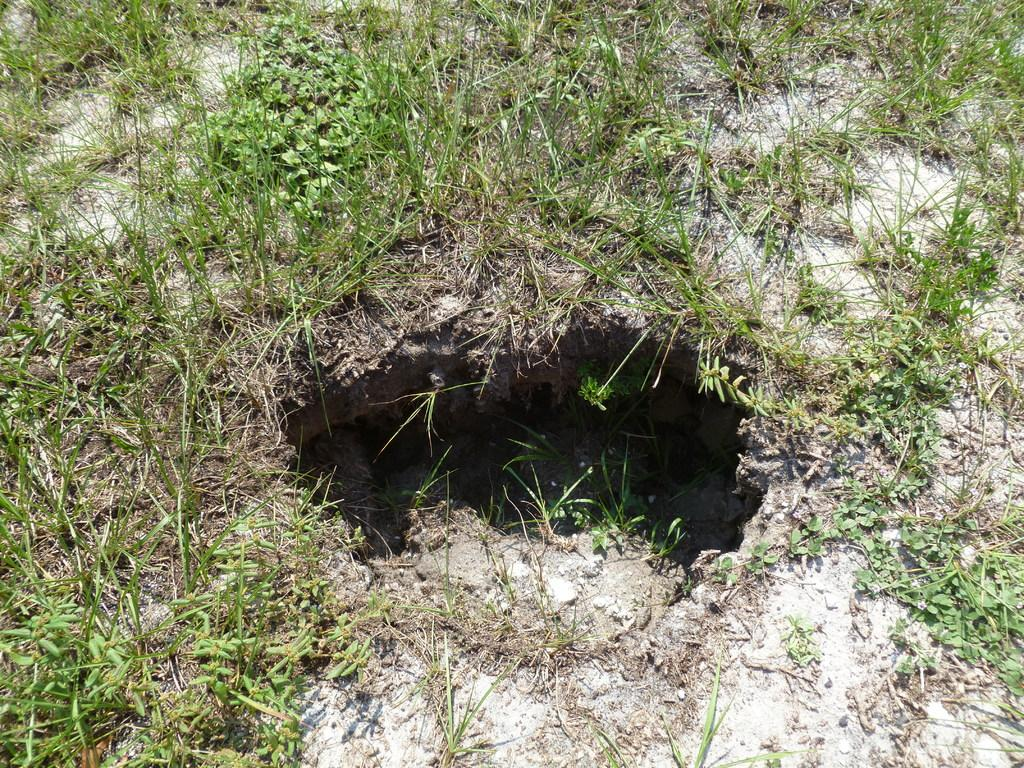What is located in the foreground of the image? There is a hole on the ground in the foreground of the image. What type of vegetation is present around the hole? The hole is surrounded by grass. What type of sugar can be seen flowing from the hole in the image? There is no sugar present in the image; it only features a hole on the ground surrounded by grass. 